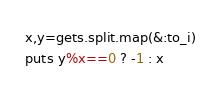<code> <loc_0><loc_0><loc_500><loc_500><_Ruby_>x,y=gets.split.map(&:to_i)
puts y%x==0 ? -1 : x</code> 